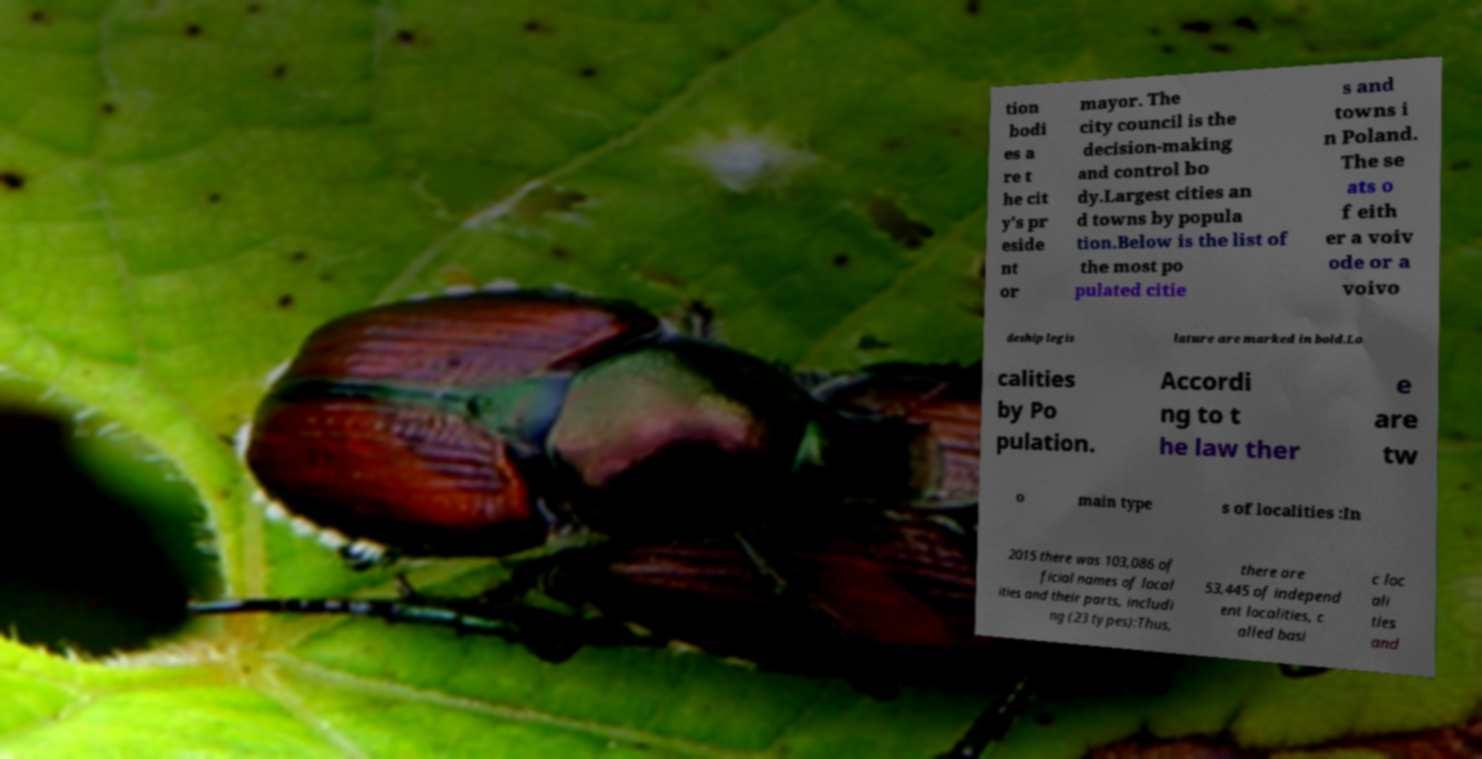For documentation purposes, I need the text within this image transcribed. Could you provide that? tion bodi es a re t he cit y's pr eside nt or mayor. The city council is the decision-making and control bo dy.Largest cities an d towns by popula tion.Below is the list of the most po pulated citie s and towns i n Poland. The se ats o f eith er a voiv ode or a voivo deship legis lature are marked in bold.Lo calities by Po pulation. Accordi ng to t he law ther e are tw o main type s of localities :In 2015 there was 103,086 of ficial names of local ities and their parts, includi ng (23 types):Thus, there are 53,445 of independ ent localities, c alled basi c loc ali ties and 